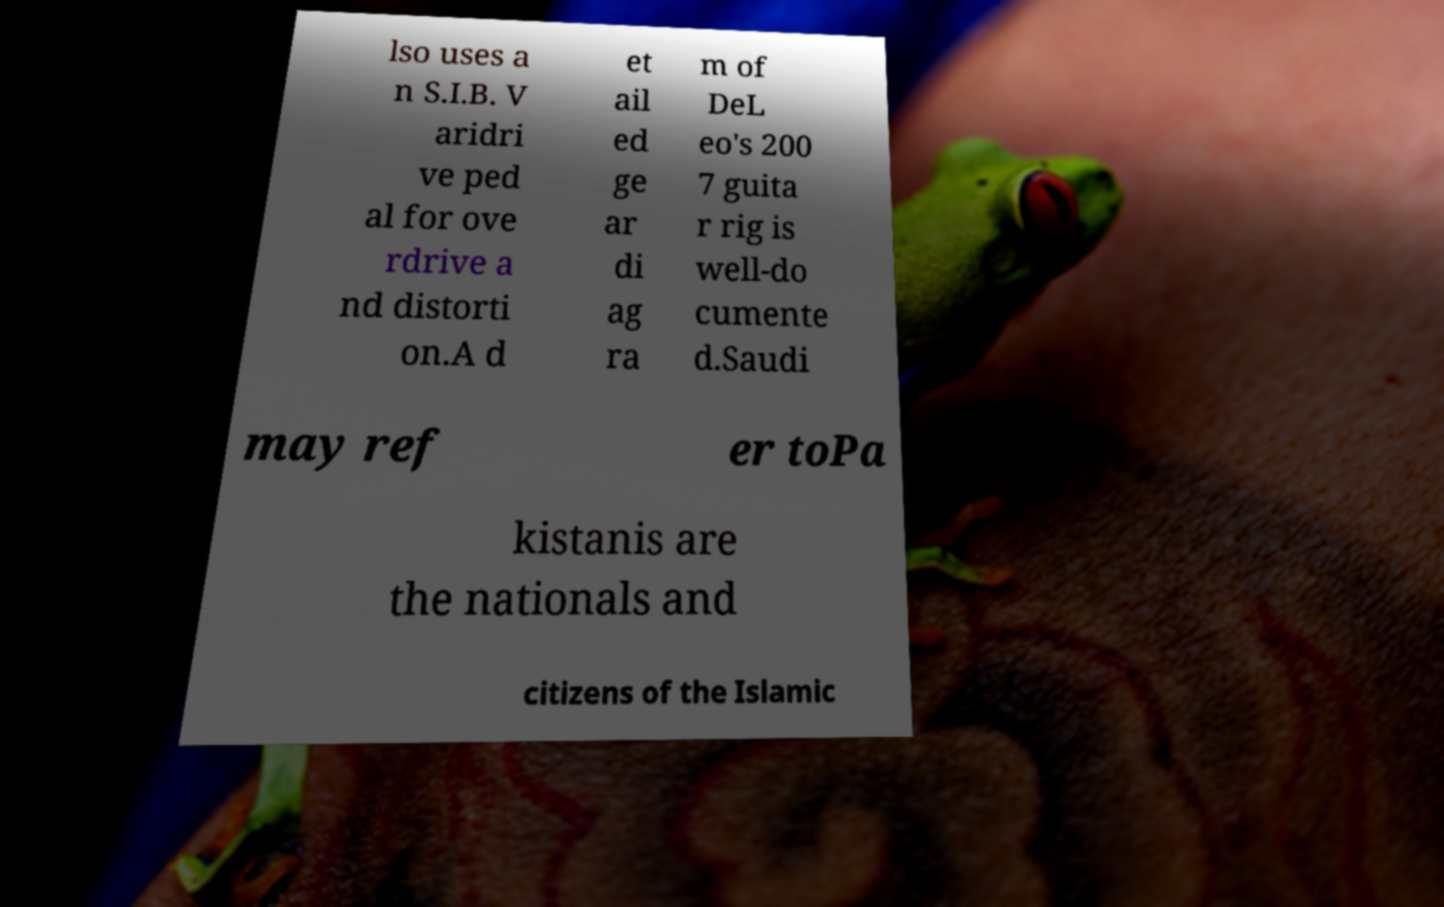Please identify and transcribe the text found in this image. lso uses a n S.I.B. V aridri ve ped al for ove rdrive a nd distorti on.A d et ail ed ge ar di ag ra m of DeL eo's 200 7 guita r rig is well-do cumente d.Saudi may ref er toPa kistanis are the nationals and citizens of the Islamic 